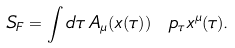<formula> <loc_0><loc_0><loc_500><loc_500>S _ { F } = \int d \tau \, A _ { \mu } ( x ( \tau ) ) \ p _ { \tau } x ^ { \mu } ( \tau ) .</formula> 